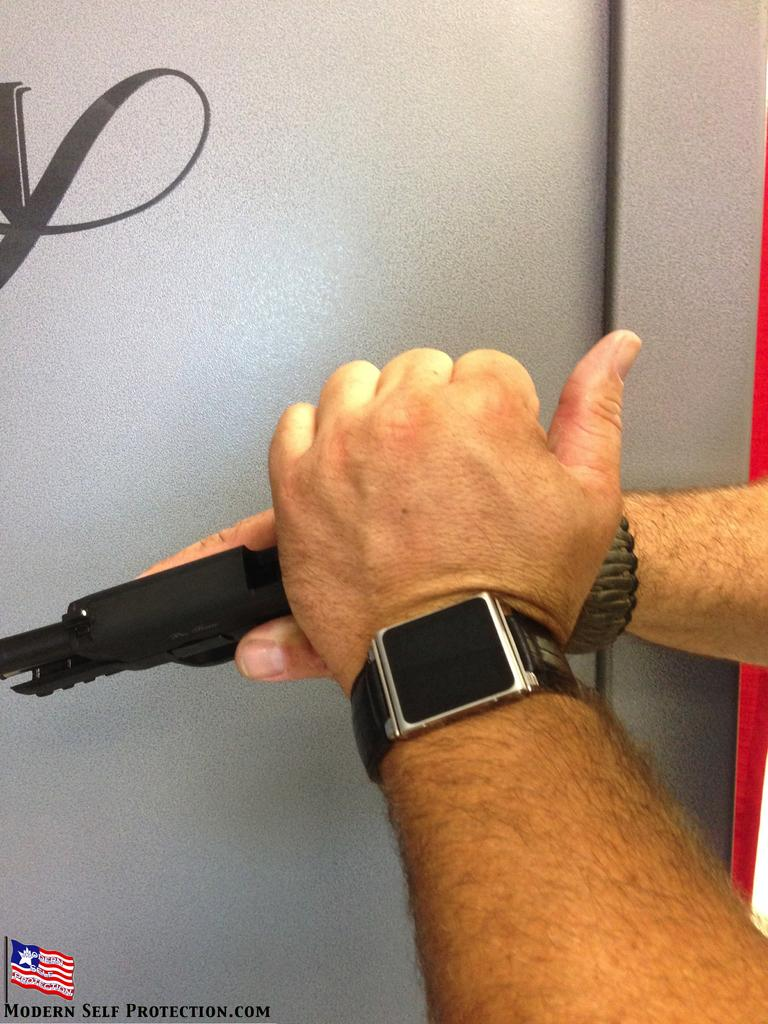<image>
Present a compact description of the photo's key features. an ad for Modern Self Protection shows a person with a gun 